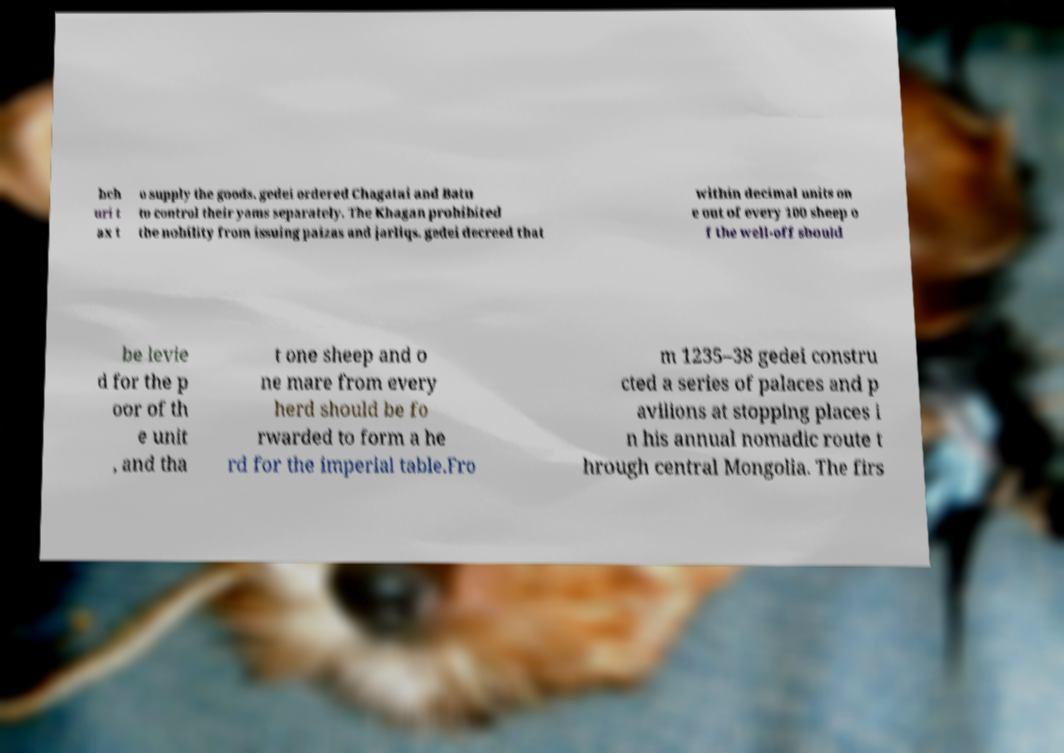Can you accurately transcribe the text from the provided image for me? bch uri t ax t o supply the goods. gedei ordered Chagatai and Batu to control their yams separately. The Khagan prohibited the nobility from issuing paizas and jarliqs. gedei decreed that within decimal units on e out of every 100 sheep o f the well-off should be levie d for the p oor of th e unit , and tha t one sheep and o ne mare from every herd should be fo rwarded to form a he rd for the imperial table.Fro m 1235–38 gedei constru cted a series of palaces and p avilions at stopping places i n his annual nomadic route t hrough central Mongolia. The firs 